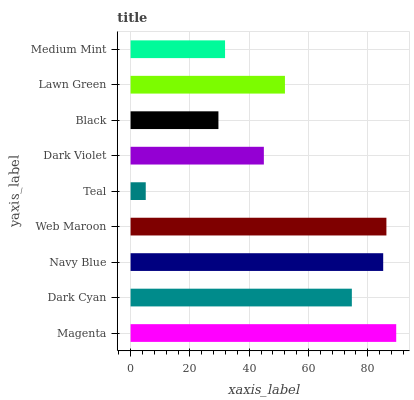Is Teal the minimum?
Answer yes or no. Yes. Is Magenta the maximum?
Answer yes or no. Yes. Is Dark Cyan the minimum?
Answer yes or no. No. Is Dark Cyan the maximum?
Answer yes or no. No. Is Magenta greater than Dark Cyan?
Answer yes or no. Yes. Is Dark Cyan less than Magenta?
Answer yes or no. Yes. Is Dark Cyan greater than Magenta?
Answer yes or no. No. Is Magenta less than Dark Cyan?
Answer yes or no. No. Is Lawn Green the high median?
Answer yes or no. Yes. Is Lawn Green the low median?
Answer yes or no. Yes. Is Navy Blue the high median?
Answer yes or no. No. Is Dark Violet the low median?
Answer yes or no. No. 